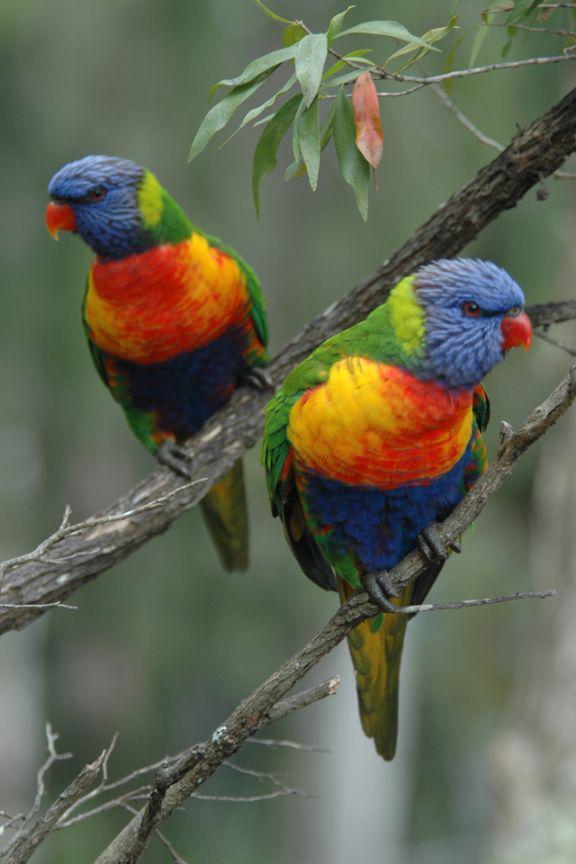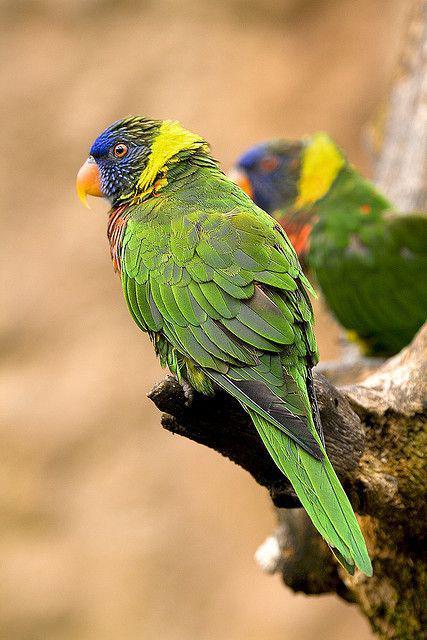The first image is the image on the left, the second image is the image on the right. Considering the images on both sides, is "There are exactly two birds in the image on the right." valid? Answer yes or no. Yes. 